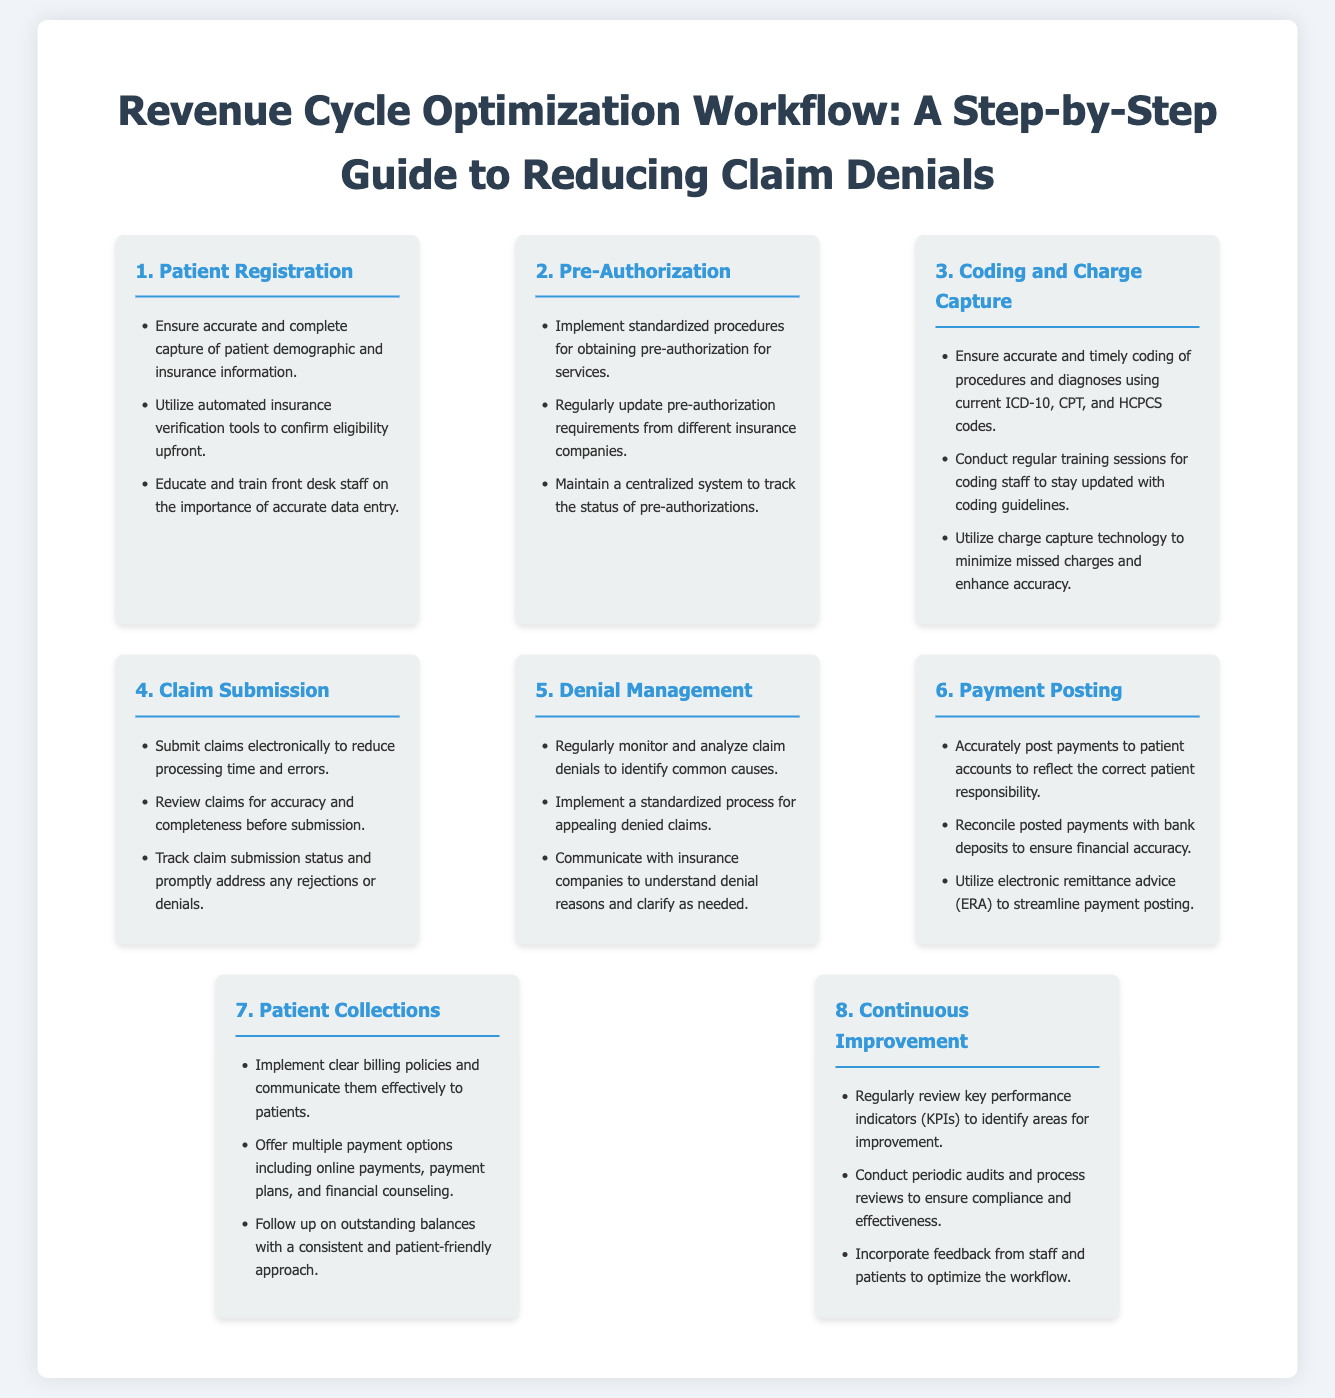What is the first step in the workflow? The first step in the revenue cycle optimization workflow is Patient Registration.
Answer: Patient Registration What is one tool recommended for confirming eligibility? The document recommends utilizing automated insurance verification tools to confirm eligibility upfront.
Answer: Automated insurance verification tools How many steps are outlined in the workflow? The infographic outlines a total of eight steps for the revenue cycle optimization process.
Answer: Eight What is the focus of the Denial Management step? The Denial Management step focuses on regularly monitoring and analyzing claim denials to identify common causes.
Answer: Analyzing claim denials Which step involves payment reconciliation? The Payment Posting step involves accurately posting payments to patient accounts and reconciling posted payments with bank deposits.
Answer: Payment Posting What is a recommendation for patient collections? The document recommends implementing clear billing policies and communicating them effectively to patients.
Answer: Clear billing policies What is the main purpose of the Continuous Improvement step? The main purpose of the Continuous Improvement step is to regularly review key performance indicators to identify areas for improvement.
Answer: Reviewing key performance indicators What type of advice should be utilized in Payment Posting? The infographic suggests utilizing electronic remittance advice (ERA) to streamline payment posting.
Answer: Electronic remittance advice 